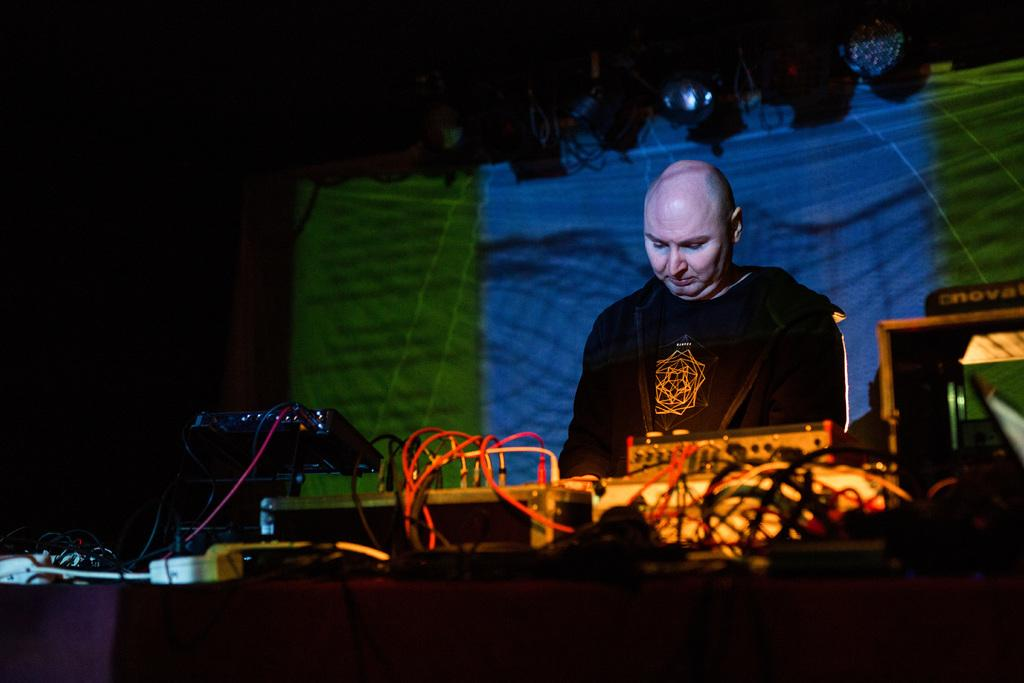Who is present in the image? There is a man in the image. Where is the man located in the image? The man is on the right side of the image. What is in front of the man? There is an equipment in front of the man. What can be seen in the background of the image? There is a screen visible in the background of the image. What type of rabbit is sitting on the man's shoulder in the image? There is no rabbit present in the image; only the man, equipment, and screen are visible. Can you tell me how many flies are buzzing around the man in the image? There are no flies present in the image. 